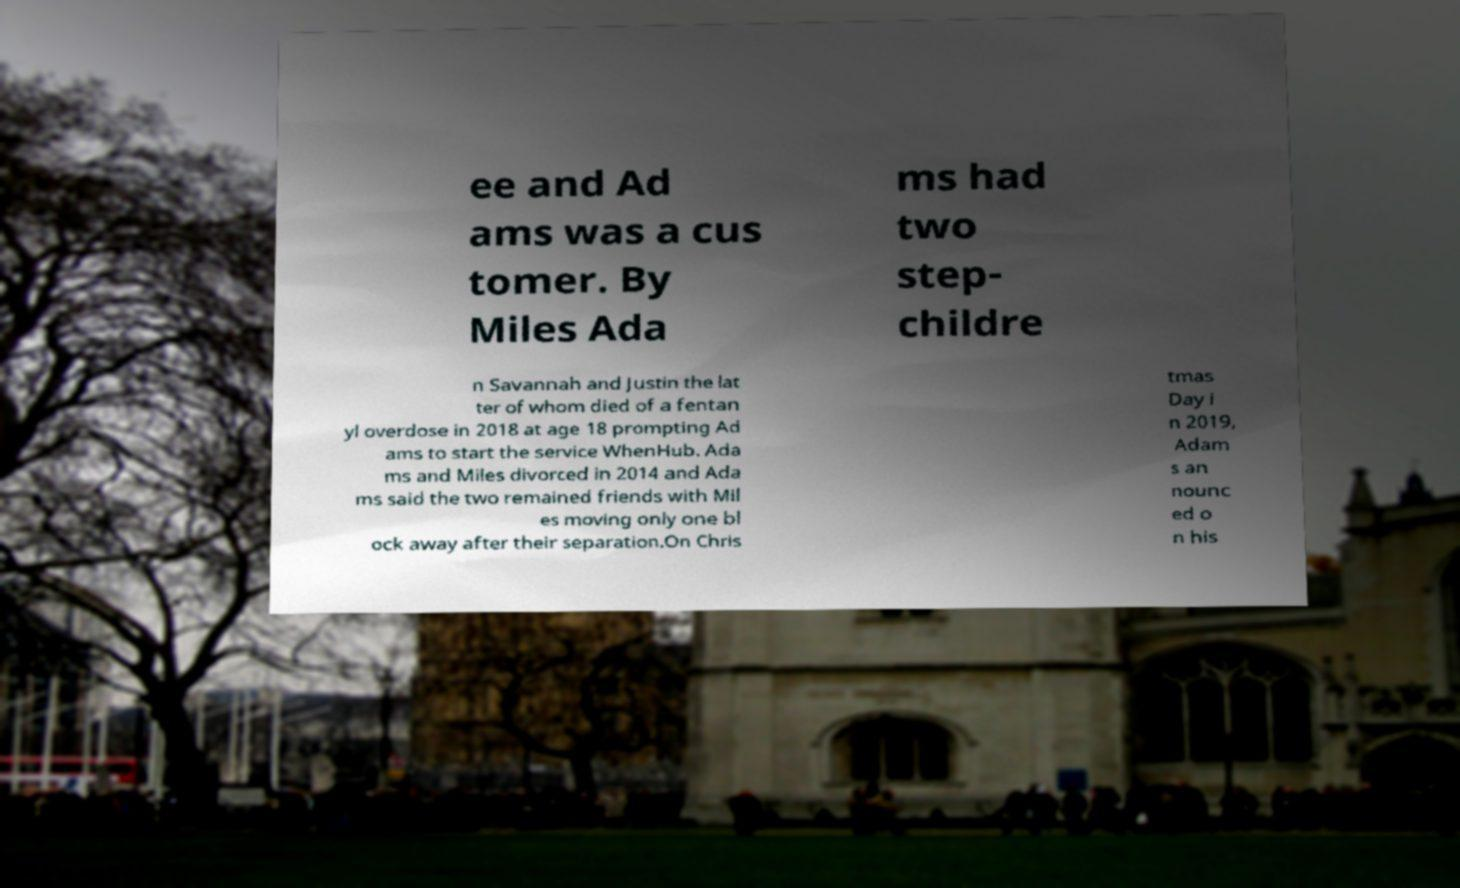For documentation purposes, I need the text within this image transcribed. Could you provide that? ee and Ad ams was a cus tomer. By Miles Ada ms had two step- childre n Savannah and Justin the lat ter of whom died of a fentan yl overdose in 2018 at age 18 prompting Ad ams to start the service WhenHub. Ada ms and Miles divorced in 2014 and Ada ms said the two remained friends with Mil es moving only one bl ock away after their separation.On Chris tmas Day i n 2019, Adam s an nounc ed o n his 